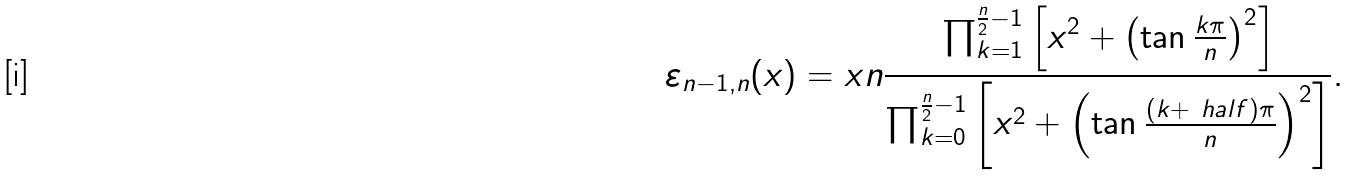Convert formula to latex. <formula><loc_0><loc_0><loc_500><loc_500>\varepsilon _ { n - 1 , n } ( x ) = x n \frac { \prod _ { k = 1 } ^ { \frac { n } { 2 } - 1 } \left [ x ^ { 2 } + \left ( \tan \frac { k \pi } n \right ) ^ { 2 } \right ] } { \prod _ { k = 0 } ^ { \frac { n } { 2 } - 1 } \left [ x ^ { 2 } + \left ( \tan \frac { ( k + \ h a l f ) \pi } n \right ) ^ { 2 } \right ] } .</formula> 